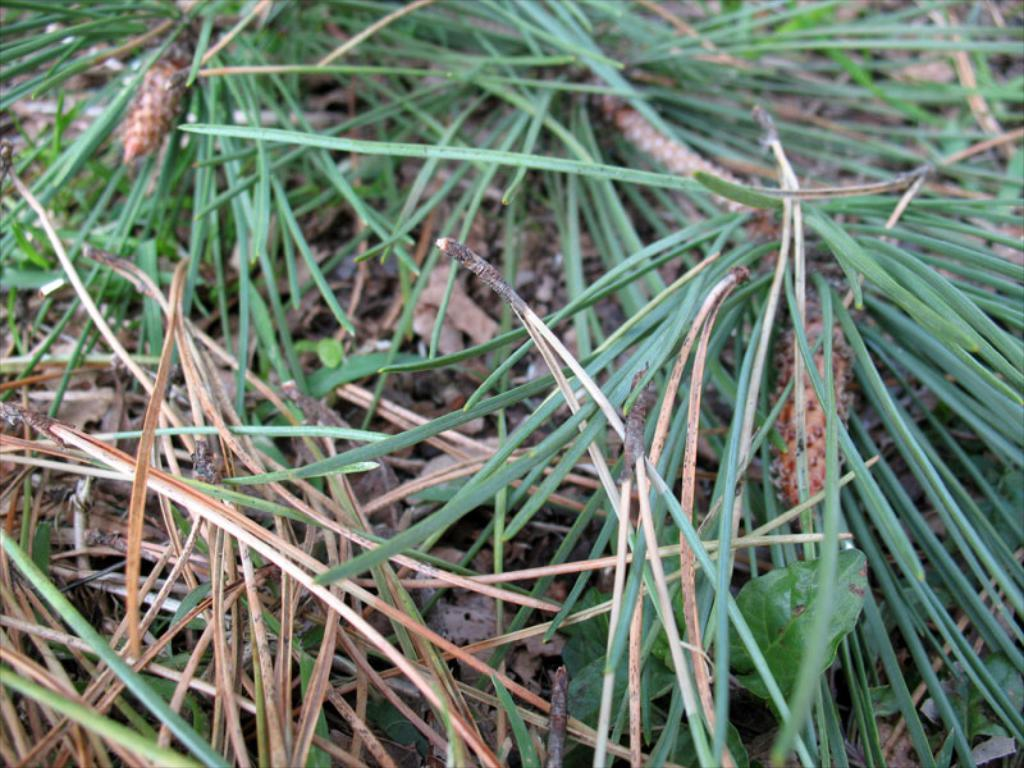What type of surface is on the floor in the image? There is grass on the floor in the image. What can be seen beneath the grass in the image? There is soil visible in the image. What other natural elements are present in the image? There are twigs in the image. Who won the competition in the image? There is no competition present in the image. What type of paper is visible in the image? There is no paper visible in the image. 